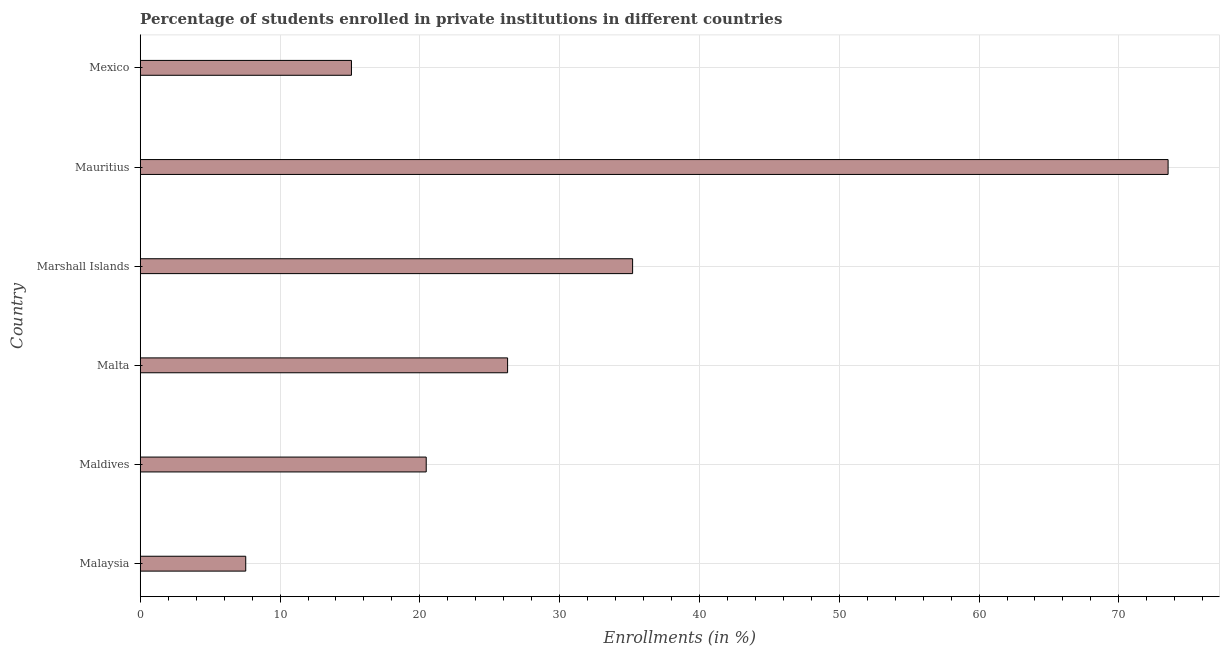Does the graph contain any zero values?
Provide a succinct answer. No. What is the title of the graph?
Ensure brevity in your answer.  Percentage of students enrolled in private institutions in different countries. What is the label or title of the X-axis?
Your answer should be compact. Enrollments (in %). What is the enrollments in private institutions in Marshall Islands?
Provide a short and direct response. 35.22. Across all countries, what is the maximum enrollments in private institutions?
Give a very brief answer. 73.52. Across all countries, what is the minimum enrollments in private institutions?
Offer a terse response. 7.55. In which country was the enrollments in private institutions maximum?
Your answer should be very brief. Mauritius. In which country was the enrollments in private institutions minimum?
Offer a very short reply. Malaysia. What is the sum of the enrollments in private institutions?
Provide a short and direct response. 178.13. What is the difference between the enrollments in private institutions in Malaysia and Mexico?
Offer a very short reply. -7.56. What is the average enrollments in private institutions per country?
Offer a very short reply. 29.69. What is the median enrollments in private institutions?
Give a very brief answer. 23.37. In how many countries, is the enrollments in private institutions greater than 26 %?
Make the answer very short. 3. What is the ratio of the enrollments in private institutions in Marshall Islands to that in Mexico?
Give a very brief answer. 2.33. What is the difference between the highest and the second highest enrollments in private institutions?
Ensure brevity in your answer.  38.3. Is the sum of the enrollments in private institutions in Malaysia and Mexico greater than the maximum enrollments in private institutions across all countries?
Ensure brevity in your answer.  No. What is the difference between the highest and the lowest enrollments in private institutions?
Offer a very short reply. 65.97. How many bars are there?
Provide a short and direct response. 6. What is the difference between two consecutive major ticks on the X-axis?
Offer a very short reply. 10. Are the values on the major ticks of X-axis written in scientific E-notation?
Give a very brief answer. No. What is the Enrollments (in %) of Malaysia?
Your answer should be very brief. 7.55. What is the Enrollments (in %) of Maldives?
Offer a very short reply. 20.46. What is the Enrollments (in %) in Malta?
Give a very brief answer. 26.28. What is the Enrollments (in %) in Marshall Islands?
Offer a terse response. 35.22. What is the Enrollments (in %) of Mauritius?
Provide a short and direct response. 73.52. What is the Enrollments (in %) in Mexico?
Provide a succinct answer. 15.11. What is the difference between the Enrollments (in %) in Malaysia and Maldives?
Your response must be concise. -12.91. What is the difference between the Enrollments (in %) in Malaysia and Malta?
Provide a succinct answer. -18.73. What is the difference between the Enrollments (in %) in Malaysia and Marshall Islands?
Your answer should be very brief. -27.67. What is the difference between the Enrollments (in %) in Malaysia and Mauritius?
Offer a very short reply. -65.97. What is the difference between the Enrollments (in %) in Malaysia and Mexico?
Your answer should be very brief. -7.56. What is the difference between the Enrollments (in %) in Maldives and Malta?
Offer a terse response. -5.82. What is the difference between the Enrollments (in %) in Maldives and Marshall Islands?
Offer a very short reply. -14.76. What is the difference between the Enrollments (in %) in Maldives and Mauritius?
Your response must be concise. -53.07. What is the difference between the Enrollments (in %) in Maldives and Mexico?
Your answer should be compact. 5.35. What is the difference between the Enrollments (in %) in Malta and Marshall Islands?
Keep it short and to the point. -8.94. What is the difference between the Enrollments (in %) in Malta and Mauritius?
Provide a short and direct response. -47.24. What is the difference between the Enrollments (in %) in Malta and Mexico?
Your answer should be compact. 11.17. What is the difference between the Enrollments (in %) in Marshall Islands and Mauritius?
Make the answer very short. -38.3. What is the difference between the Enrollments (in %) in Marshall Islands and Mexico?
Your answer should be very brief. 20.11. What is the difference between the Enrollments (in %) in Mauritius and Mexico?
Ensure brevity in your answer.  58.41. What is the ratio of the Enrollments (in %) in Malaysia to that in Maldives?
Your answer should be very brief. 0.37. What is the ratio of the Enrollments (in %) in Malaysia to that in Malta?
Give a very brief answer. 0.29. What is the ratio of the Enrollments (in %) in Malaysia to that in Marshall Islands?
Your answer should be compact. 0.21. What is the ratio of the Enrollments (in %) in Malaysia to that in Mauritius?
Your answer should be very brief. 0.1. What is the ratio of the Enrollments (in %) in Maldives to that in Malta?
Keep it short and to the point. 0.78. What is the ratio of the Enrollments (in %) in Maldives to that in Marshall Islands?
Ensure brevity in your answer.  0.58. What is the ratio of the Enrollments (in %) in Maldives to that in Mauritius?
Offer a terse response. 0.28. What is the ratio of the Enrollments (in %) in Maldives to that in Mexico?
Give a very brief answer. 1.35. What is the ratio of the Enrollments (in %) in Malta to that in Marshall Islands?
Make the answer very short. 0.75. What is the ratio of the Enrollments (in %) in Malta to that in Mauritius?
Give a very brief answer. 0.36. What is the ratio of the Enrollments (in %) in Malta to that in Mexico?
Provide a succinct answer. 1.74. What is the ratio of the Enrollments (in %) in Marshall Islands to that in Mauritius?
Make the answer very short. 0.48. What is the ratio of the Enrollments (in %) in Marshall Islands to that in Mexico?
Give a very brief answer. 2.33. What is the ratio of the Enrollments (in %) in Mauritius to that in Mexico?
Your response must be concise. 4.87. 